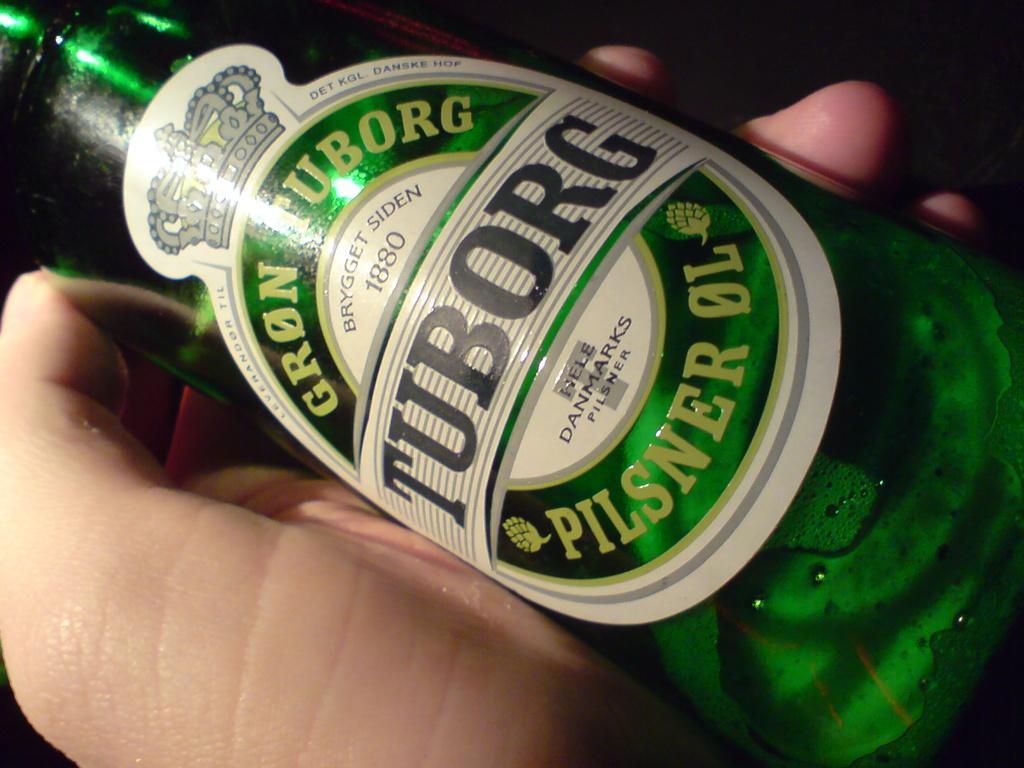In one or two sentences, can you explain what this image depicts? In this image in the center there is one bottle beside that bottle there is one persons hand. 